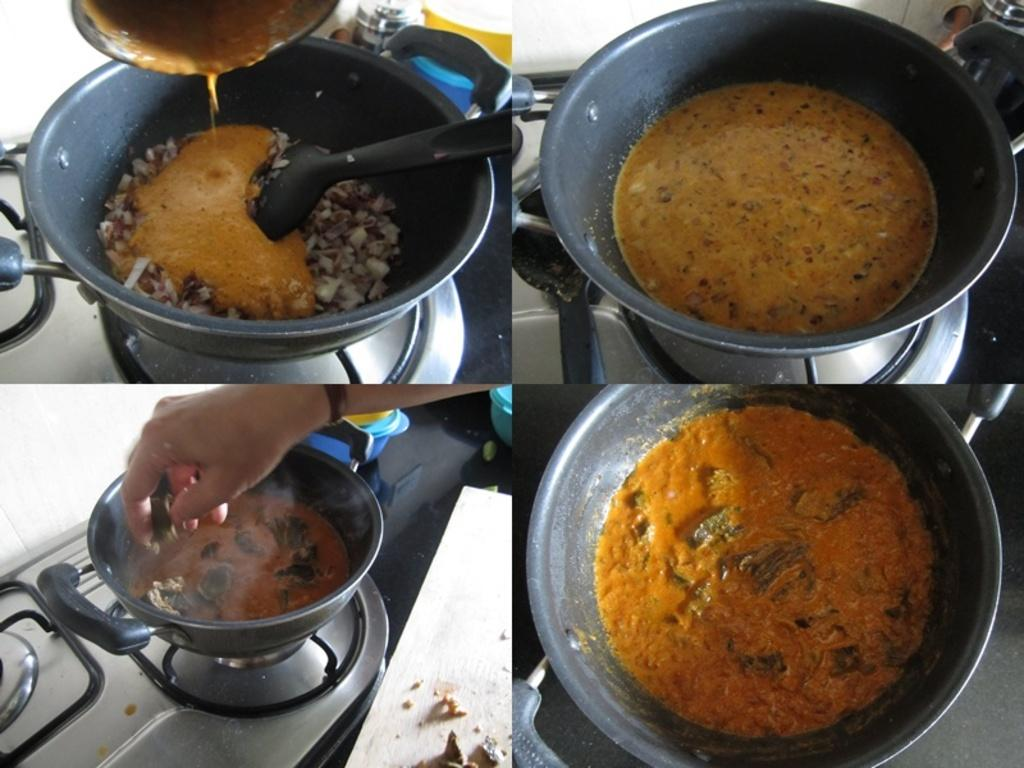What type of artwork is shown in the image? The image is a collage. How many pictures are included in the collage? There are four pictures in the collage. What is the common theme among the pictures? Each picture contains food in a bowl. Where are the bowls placed in the pictures? The bowls are placed on a stove. Can you identify any utensils in the collage? Yes, there is a spoon in at least one of the bowls. What type of treatment is being administered to the cows in the image? There are no cows present in the image; it is a collage of pictures featuring food in bowls placed on a stove. 